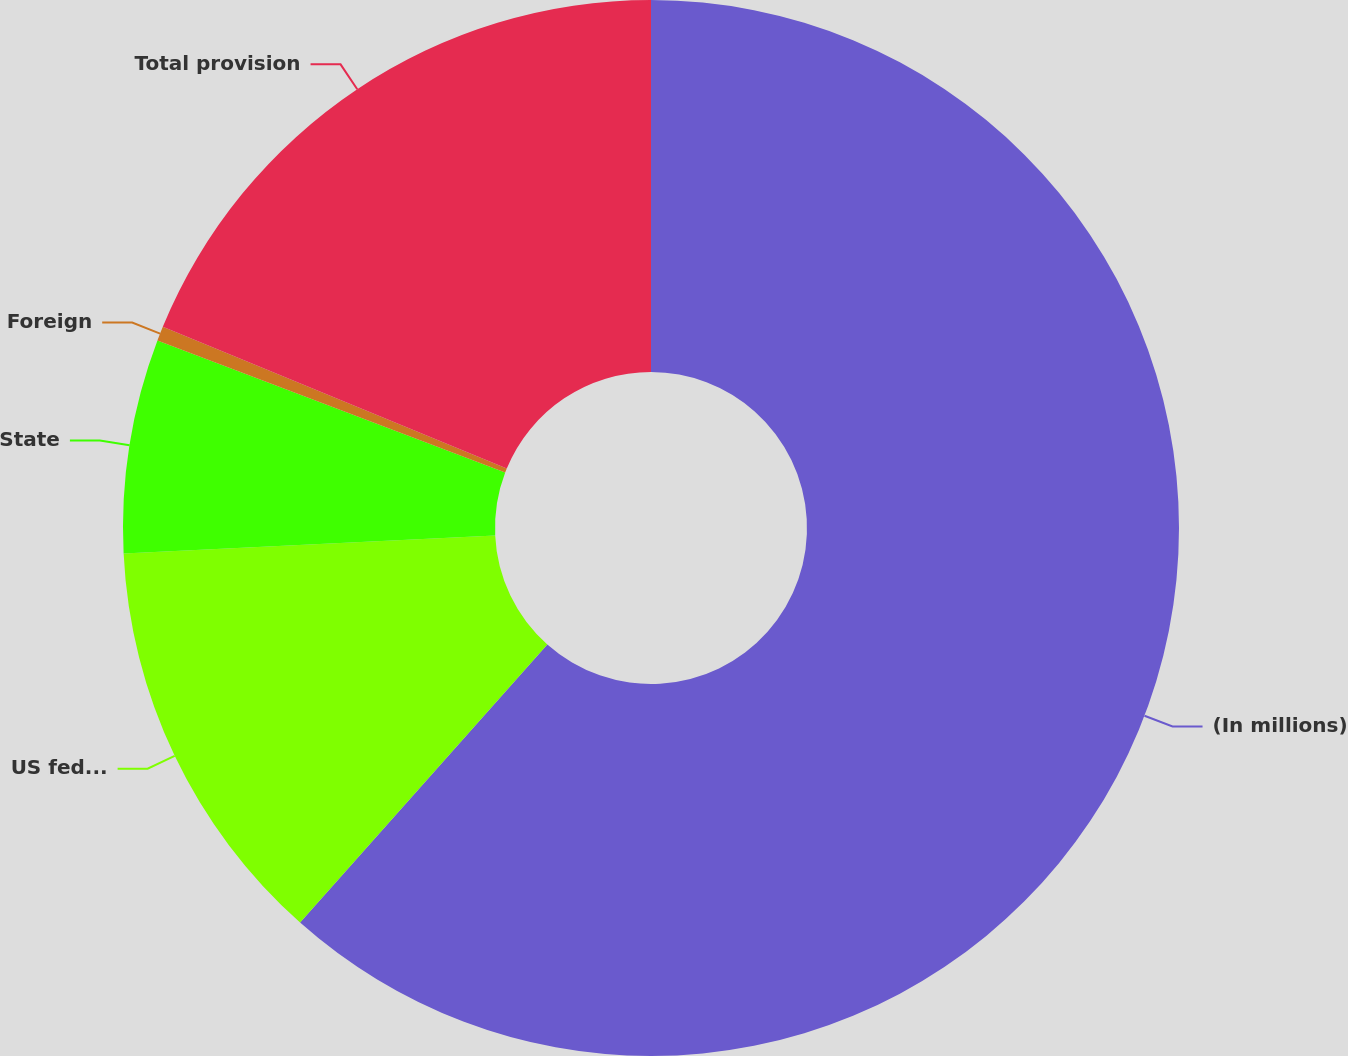Convert chart to OTSL. <chart><loc_0><loc_0><loc_500><loc_500><pie_chart><fcel>(In millions)<fcel>US federal<fcel>State<fcel>Foreign<fcel>Total provision<nl><fcel>61.57%<fcel>12.66%<fcel>6.55%<fcel>0.44%<fcel>18.78%<nl></chart> 